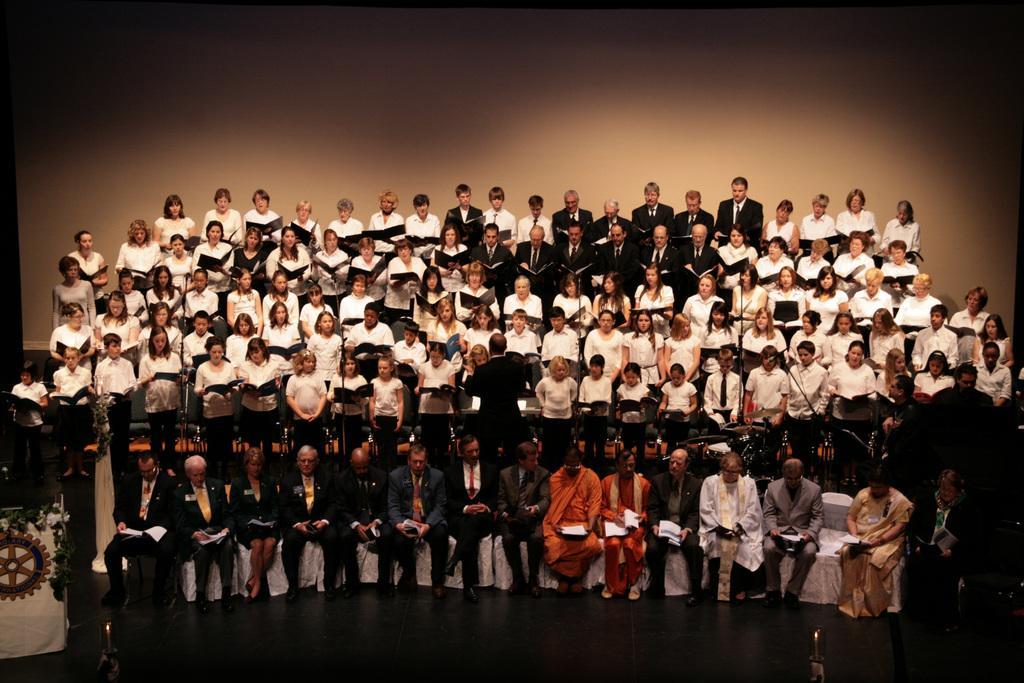In one or two sentences, can you explain what this image depicts? In this image I can see group of people standing and few people are sitting on chairs. They are holding books and wearing different color dress. 